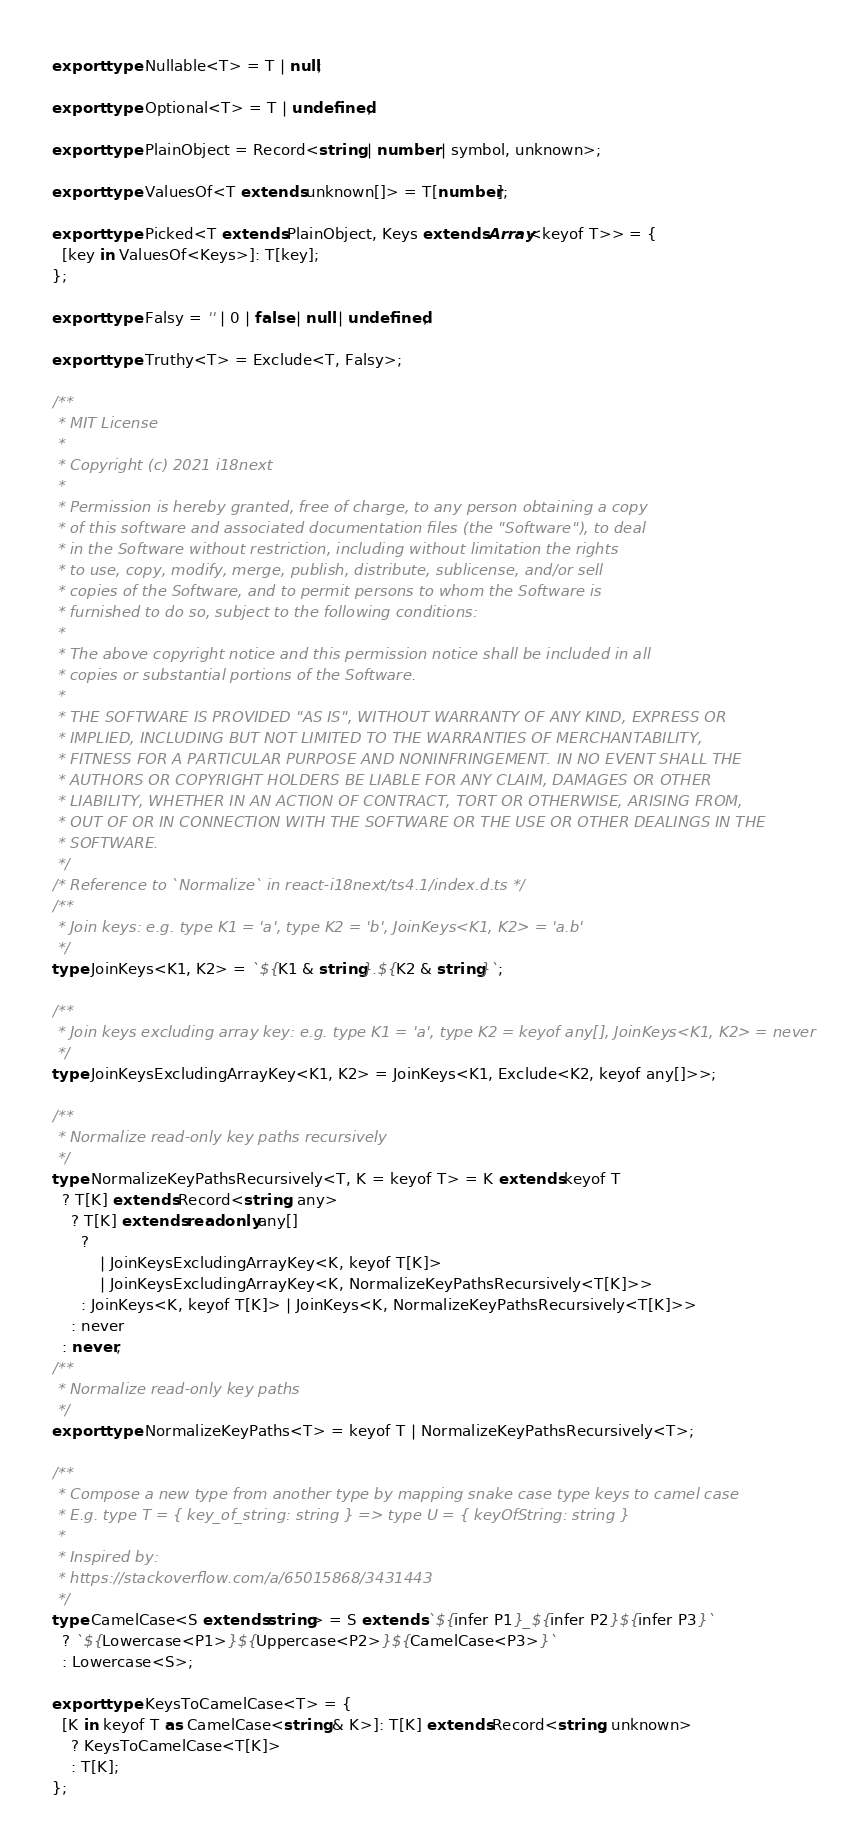<code> <loc_0><loc_0><loc_500><loc_500><_TypeScript_>export type Nullable<T> = T | null;

export type Optional<T> = T | undefined;

export type PlainObject = Record<string | number | symbol, unknown>;

export type ValuesOf<T extends unknown[]> = T[number];

export type Picked<T extends PlainObject, Keys extends Array<keyof T>> = {
  [key in ValuesOf<Keys>]: T[key];
};

export type Falsy = '' | 0 | false | null | undefined;

export type Truthy<T> = Exclude<T, Falsy>;

/**
 * MIT License
 *
 * Copyright (c) 2021 i18next
 *
 * Permission is hereby granted, free of charge, to any person obtaining a copy
 * of this software and associated documentation files (the "Software"), to deal
 * in the Software without restriction, including without limitation the rights
 * to use, copy, modify, merge, publish, distribute, sublicense, and/or sell
 * copies of the Software, and to permit persons to whom the Software is
 * furnished to do so, subject to the following conditions:
 *
 * The above copyright notice and this permission notice shall be included in all
 * copies or substantial portions of the Software.
 *
 * THE SOFTWARE IS PROVIDED "AS IS", WITHOUT WARRANTY OF ANY KIND, EXPRESS OR
 * IMPLIED, INCLUDING BUT NOT LIMITED TO THE WARRANTIES OF MERCHANTABILITY,
 * FITNESS FOR A PARTICULAR PURPOSE AND NONINFRINGEMENT. IN NO EVENT SHALL THE
 * AUTHORS OR COPYRIGHT HOLDERS BE LIABLE FOR ANY CLAIM, DAMAGES OR OTHER
 * LIABILITY, WHETHER IN AN ACTION OF CONTRACT, TORT OR OTHERWISE, ARISING FROM,
 * OUT OF OR IN CONNECTION WITH THE SOFTWARE OR THE USE OR OTHER DEALINGS IN THE
 * SOFTWARE.
 */
/* Reference to `Normalize` in react-i18next/ts4.1/index.d.ts */
/**
 * Join keys: e.g. type K1 = 'a', type K2 = 'b', JoinKeys<K1, K2> = 'a.b'
 */
type JoinKeys<K1, K2> = `${K1 & string}.${K2 & string}`;

/**
 * Join keys excluding array key: e.g. type K1 = 'a', type K2 = keyof any[], JoinKeys<K1, K2> = never
 */
type JoinKeysExcludingArrayKey<K1, K2> = JoinKeys<K1, Exclude<K2, keyof any[]>>;

/**
 * Normalize read-only key paths recursively
 */
type NormalizeKeyPathsRecursively<T, K = keyof T> = K extends keyof T
  ? T[K] extends Record<string, any>
    ? T[K] extends readonly any[]
      ?
          | JoinKeysExcludingArrayKey<K, keyof T[K]>
          | JoinKeysExcludingArrayKey<K, NormalizeKeyPathsRecursively<T[K]>>
      : JoinKeys<K, keyof T[K]> | JoinKeys<K, NormalizeKeyPathsRecursively<T[K]>>
    : never
  : never;
/**
 * Normalize read-only key paths
 */
export type NormalizeKeyPaths<T> = keyof T | NormalizeKeyPathsRecursively<T>;

/**
 * Compose a new type from another type by mapping snake case type keys to camel case
 * E.g. type T = { key_of_string: string } => type U = { keyOfString: string }
 *
 * Inspired by:
 * https://stackoverflow.com/a/65015868/3431443
 */
type CamelCase<S extends string> = S extends `${infer P1}_${infer P2}${infer P3}`
  ? `${Lowercase<P1>}${Uppercase<P2>}${CamelCase<P3>}`
  : Lowercase<S>;

export type KeysToCamelCase<T> = {
  [K in keyof T as CamelCase<string & K>]: T[K] extends Record<string, unknown>
    ? KeysToCamelCase<T[K]>
    : T[K];
};
</code> 